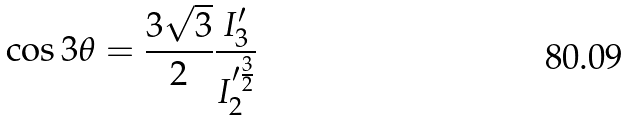<formula> <loc_0><loc_0><loc_500><loc_500>\cos 3 \theta = \frac { 3 \sqrt { 3 } } { 2 } \frac { I _ { 3 } ^ { \prime } } { I _ { 2 } ^ { \prime \frac { 3 } { 2 } } }</formula> 